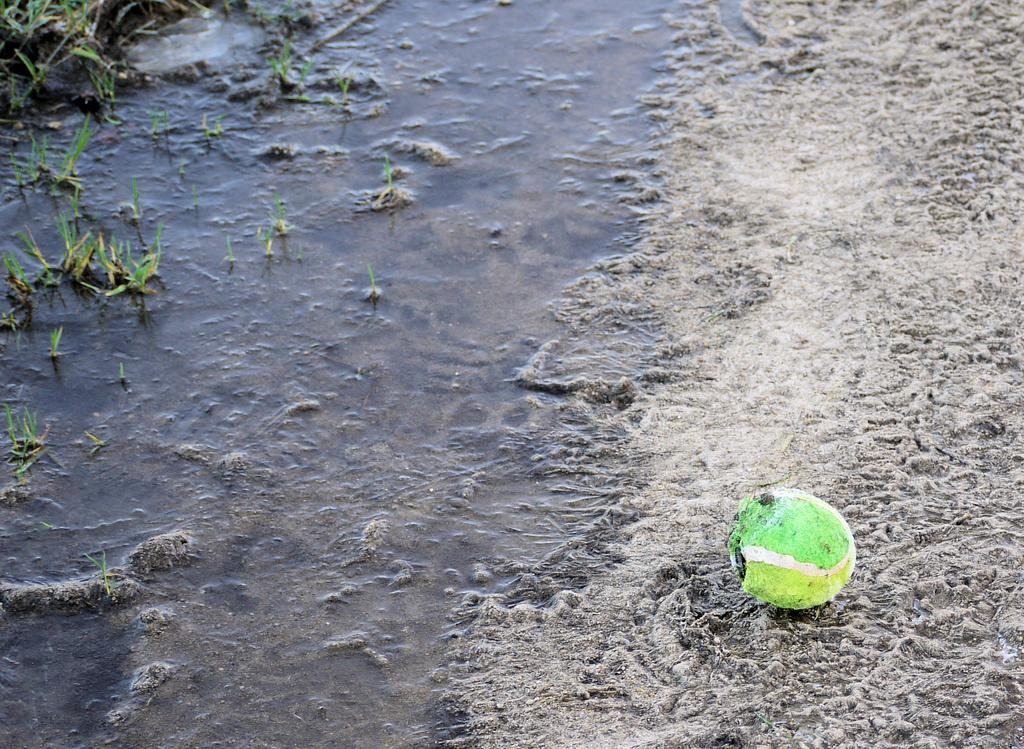What is the color of the object on the ground in the image? The object on the ground is green. What can be seen in the background of the image? Water and grass are visible in the background of the image. What type of rice is being cooked in the image? There is no rice present in the image; it features a green object on the ground and water and grass in the background. 